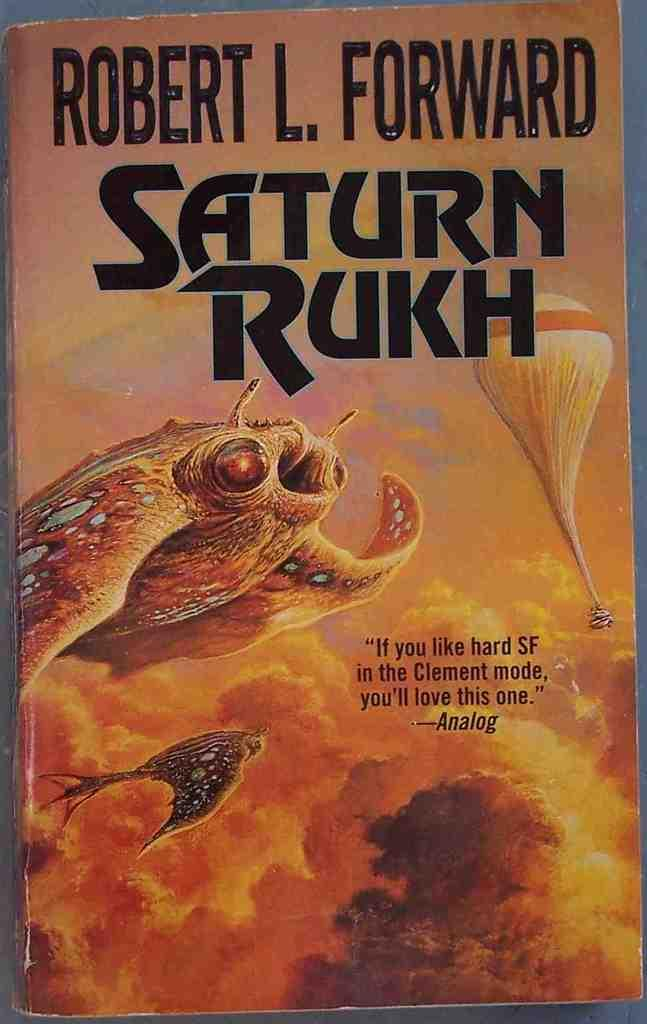<image>
Share a concise interpretation of the image provided. A paperback novel called Saturn Rukh by Robert L. Forward 